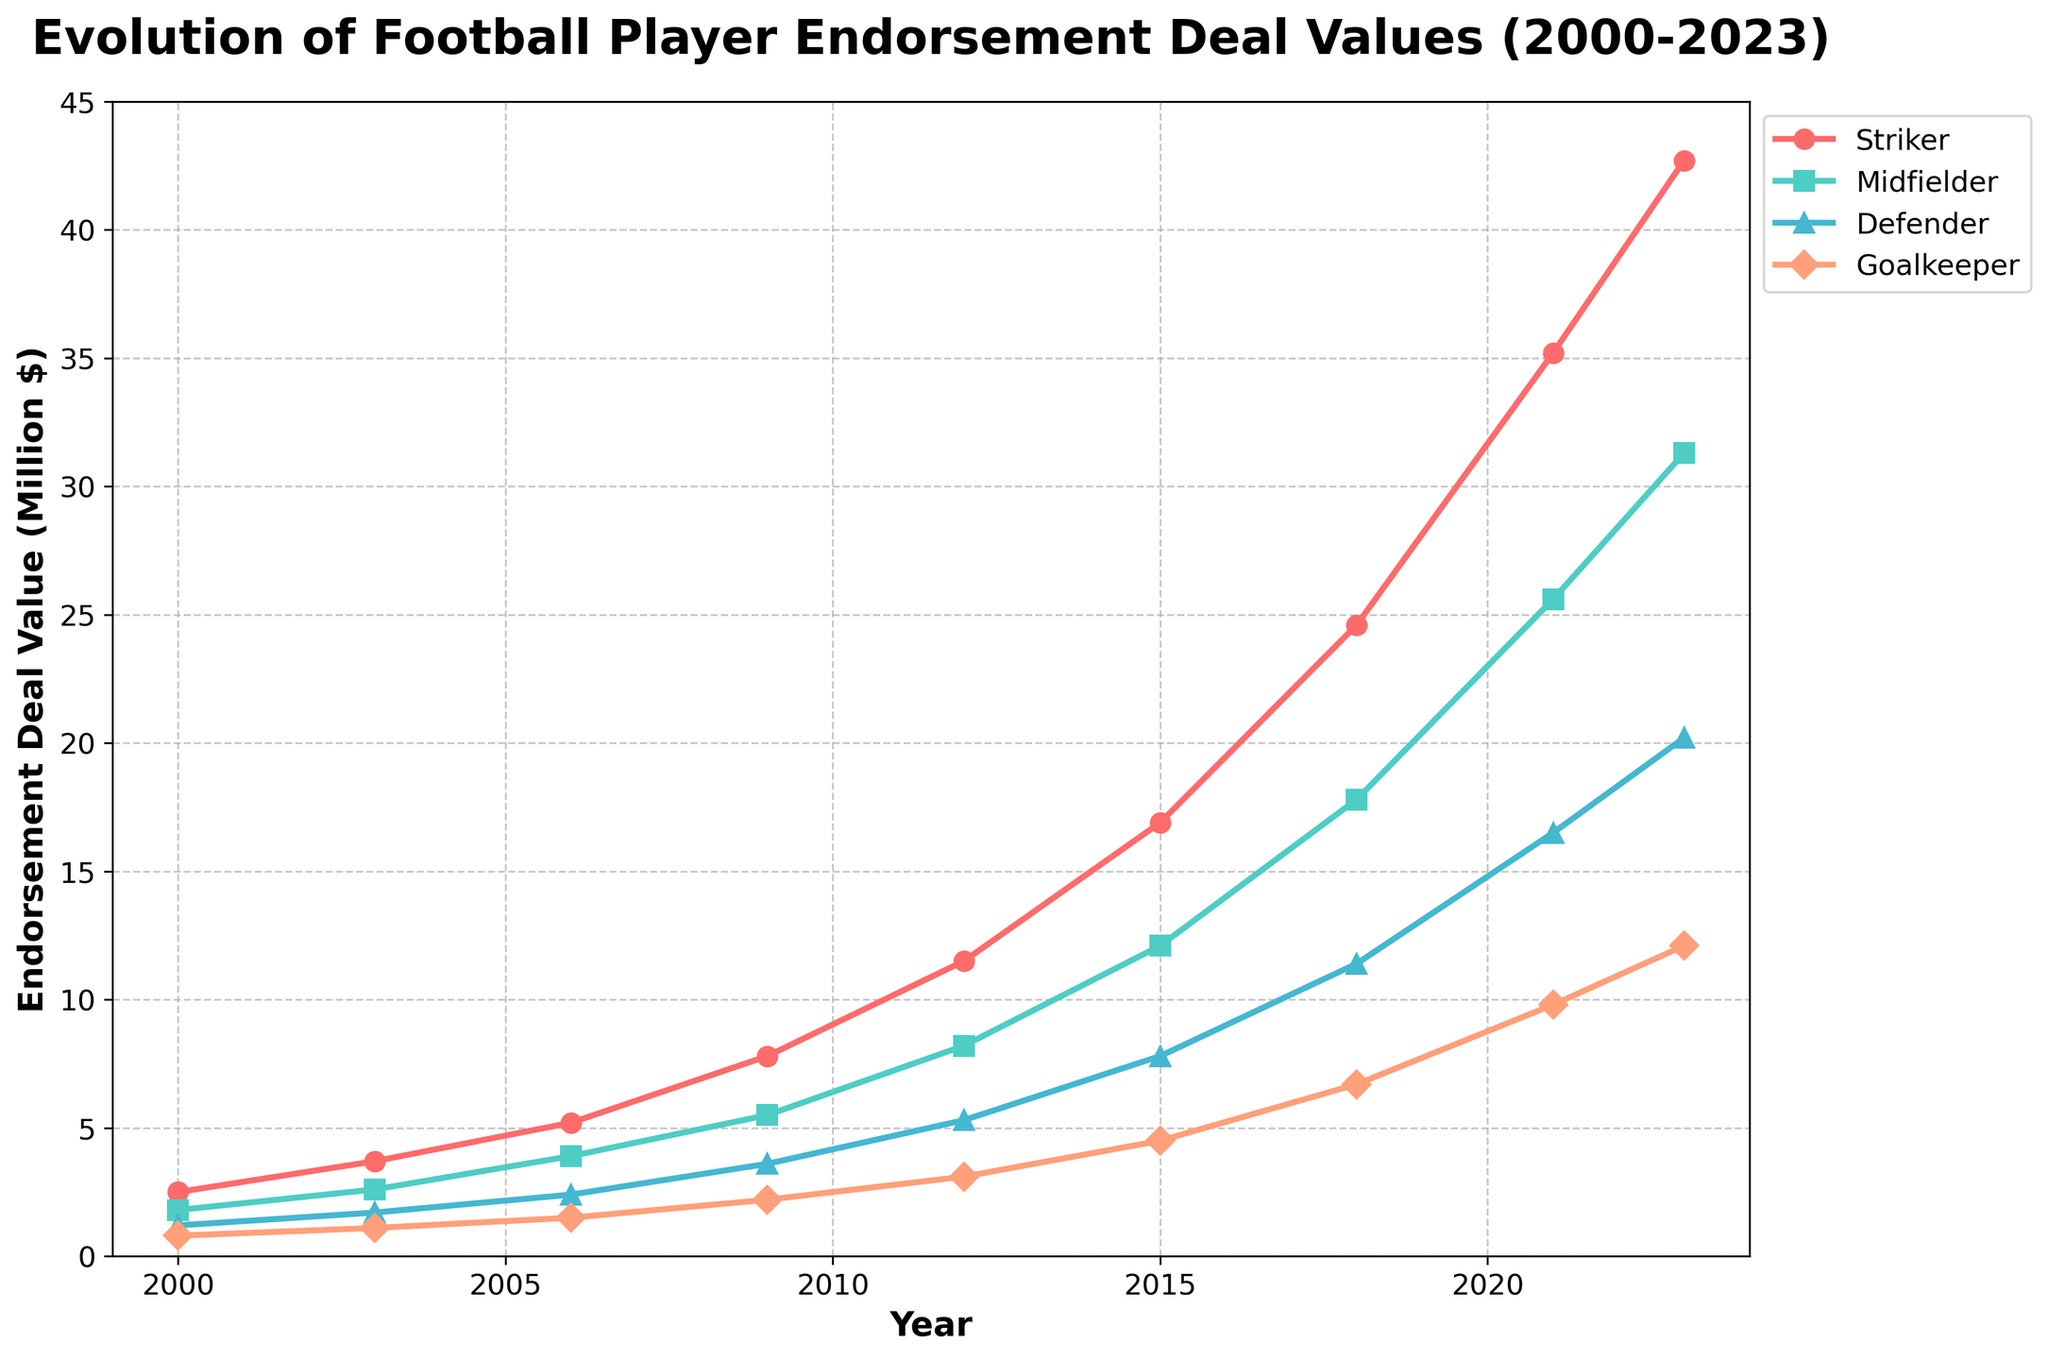What has been the overall trend in endorsement deal values for strikers from 2000 to 2023? The plot shows a line that increases steadily from 2.5 million dollars in 2000 to 42.7 million dollars in 2023, indicating a significant rise in endorsement deal values for strikers over this period.
Answer: Increasing Which player position saw the highest endorsement deal value in 2023? In 2023, the striker position had the highest endorsement deal value at 42.7 million dollars. This can be determined by observing the endpoints of the lines on the right side of the plot.
Answer: Striker By how much did the endorsement deal value for midfielders increase between 2012 and 2023? The endorsement deal values for midfielders increased from 8.2 million dollars in 2012 to 31.3 million dollars in 2023. The increase can be calculated as 31.3 - 8.2 = 23.1.
Answer: 23.1 million dollars Which year saw the fastest growth in endorsement deal values for defenders? The steepest slope for the defender's line appears between 2009 and 2012, indicating the fastest growth in endorsement values during these years. Values increased from 3.6 million to 5.3 million, a rise of 1.7 million dollars.
Answer: 2009-2012 How do the endorsement deal values for goalkeepers in 2023 compare to those for strikers in 2015? In 2023, the endorsement deal value for goalkeepers is 12.1 million dollars, while for strikers in 2015, it was 16.9 million dollars. The comparison indicates values for goalkeepers in 2023 are lower than those for strikers in 2015.
Answer: Lower What is the average endorsement deal value for defenders over the entire period? Adding the values for defenders over the years (1.2 + 1.7 + 2.4 + 3.6 + 5.3 + 7.8 + 11.4 + 16.5 + 20.2) and then dividing by the number of years (9) gives an average. (1.2 + 1.7 + 2.4 + 3.6 + 5.3 + 7.8 + 11.4 + 16.5 + 20.2) / 9 = 7.0111 (approx).
Answer: Approximately 7.01 million dollars Which period experienced the highest absolute increase in endorsement deal value for strikers? The period can be identified by the steepest segment of the line for strikers. From 2018 (24.6 million) to 2021 (35.2 million), the increase was 35.2 - 24.6 = 10.6 million dollars, the highest for any period.
Answer: 2018-2021 What is the visual color and shape of the markers for midfielders on the plot? Midfielders are represented by a line with green markers in the shape of squares on the chart.
Answer: Green squares 